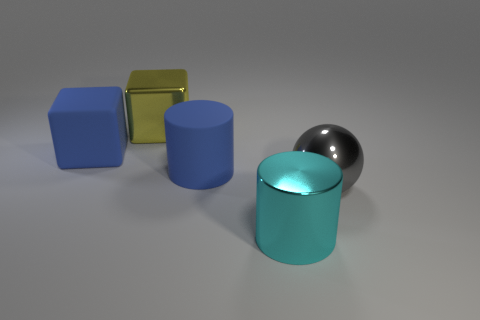Is the size of the blue rubber object that is to the right of the big metal cube the same as the metallic thing that is behind the metallic ball?
Your response must be concise. Yes. What number of large spheres are there?
Provide a succinct answer. 1. What is the size of the object that is on the left side of the large metallic thing left of the big cylinder behind the cyan metallic cylinder?
Offer a terse response. Large. Is the big matte block the same color as the metallic block?
Ensure brevity in your answer.  No. Are there any other things that have the same size as the cyan object?
Provide a short and direct response. Yes. What number of blue matte objects are in front of the big ball?
Your answer should be compact. 0. Are there the same number of yellow things that are on the left side of the large yellow object and metallic spheres?
Your response must be concise. No. What number of objects are either large red shiny spheres or big matte things?
Offer a very short reply. 2. Is there anything else that has the same shape as the big cyan shiny object?
Your response must be concise. Yes. What is the shape of the large metallic thing that is right of the metallic thing that is in front of the big gray object?
Give a very brief answer. Sphere. 